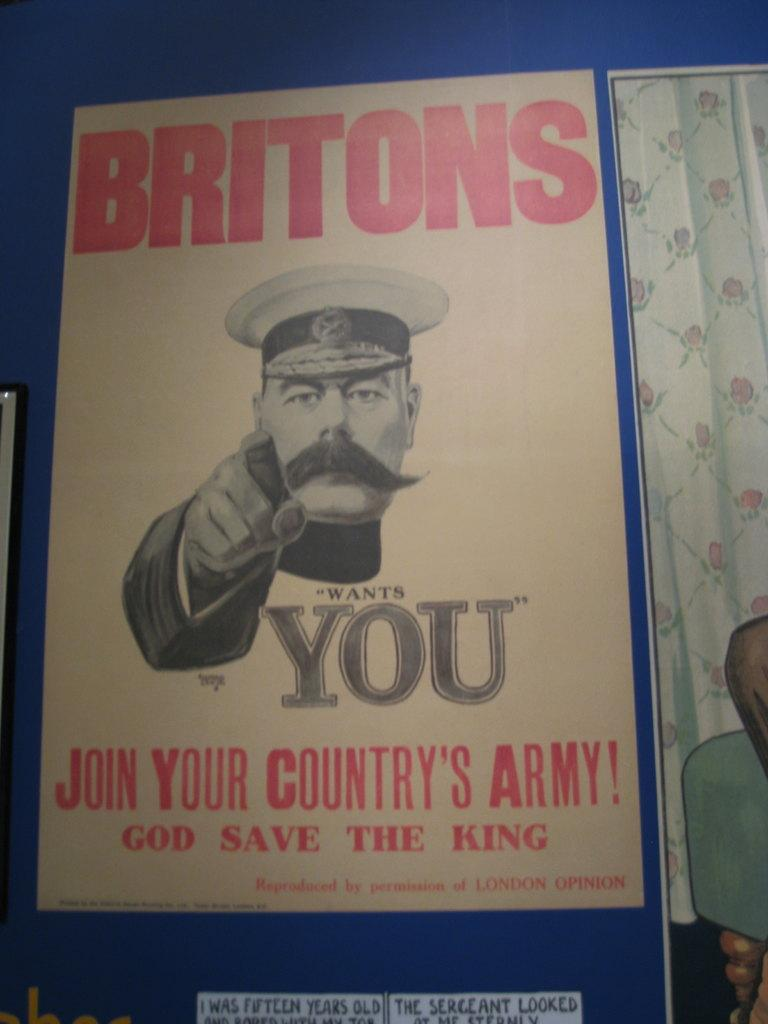What is present in the image that contains a picture? There is a poster in the image that contains a picture. What else can be found on the poster besides the picture? There is text written on the poster. How many daughters are visible in the image? There is no daughter present in the image; it only features a poster with a picture and text. 